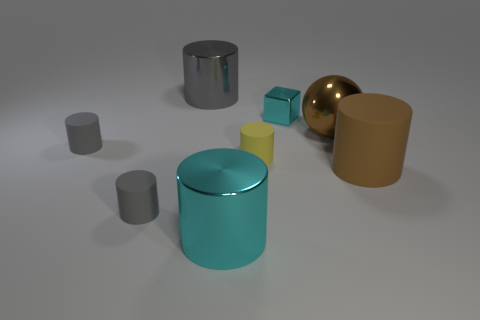Can you describe the colors and shapes of the objects in the image? Certainly! The image features a collection of geometric shapes in various colors. From left to right, there's a small gray cylinder, a large shiny silver cylinder, a teal cylinder that's medium-sized, a small aqua cube, a golden sphere, and a large matte beige cylinder. The arrangement on a neutral background puts an emphasis on the differences in color and size among the shapes. 